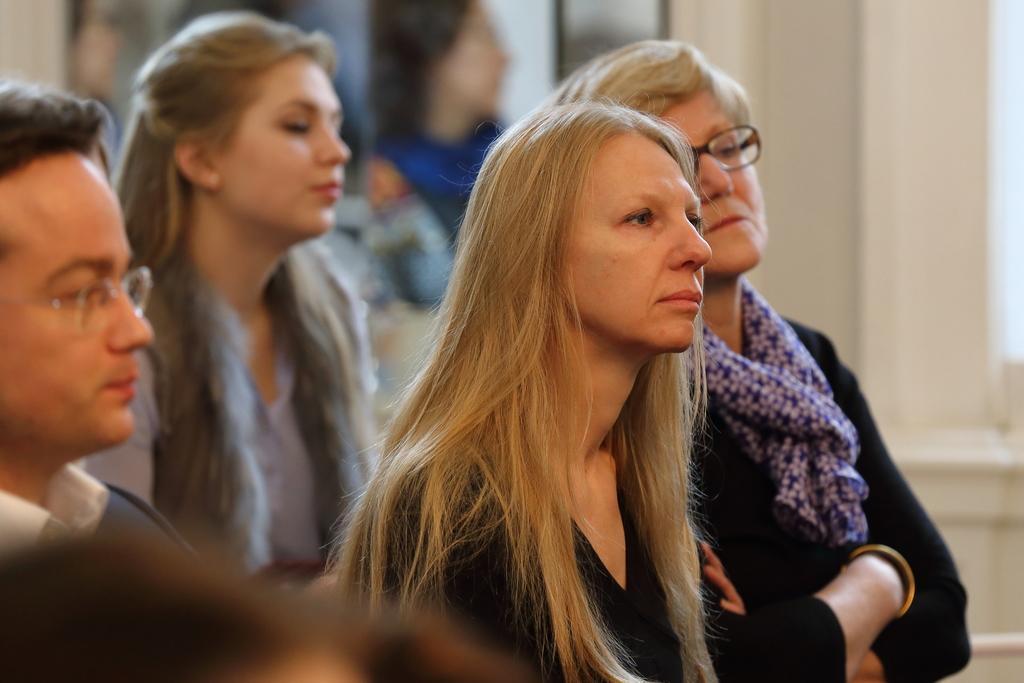In one or two sentences, can you explain what this image depicts? There are three women and a man standing. This looks like a pillar. The background looks blurry. 